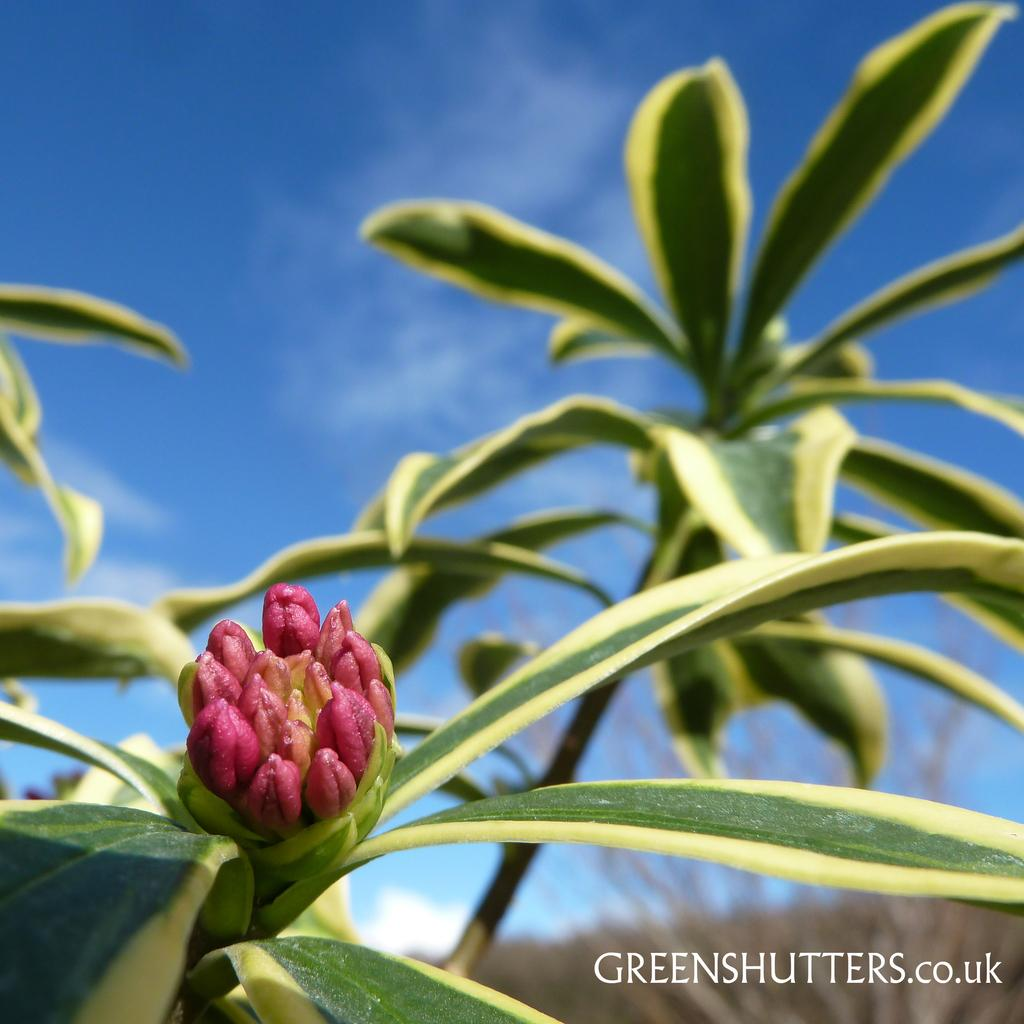What type of living organisms are present in the image? There are plants in the image. What specific features can be observed on the plants? The plants have leaves and a bud. What is visible in the background of the image? The sky is visible in the image. How would you describe the weather based on the appearance of the sky? The sky appears cloudy in the image. What type of fireman equipment can be seen in the image? There is no fireman or fireman equipment present in the image. Can you tell me how many baseballs are visible in the image? There are no baseballs present in the image. 